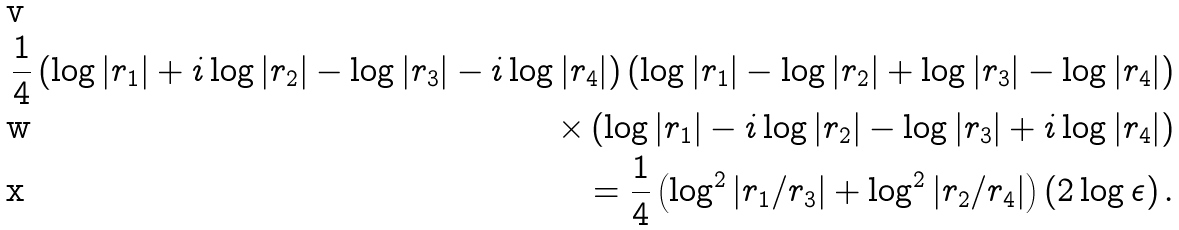Convert formula to latex. <formula><loc_0><loc_0><loc_500><loc_500>\frac { 1 } { 4 } \left ( \log | r _ { 1 } | + i \log | r _ { 2 } | - \log | r _ { 3 } | - i \log | r _ { 4 } | \right ) \left ( \log | r _ { 1 } | - \log | r _ { 2 } | + \log | r _ { 3 } | - \log | r _ { 4 } | \right ) \\ \times \left ( \log | r _ { 1 } | - i \log | r _ { 2 } | - \log | r _ { 3 } | + i \log | r _ { 4 } | \right ) \\ = \frac { 1 } { 4 } \left ( \log ^ { 2 } | r _ { 1 } / r _ { 3 } | + \log ^ { 2 } | r _ { 2 } / r _ { 4 } | \right ) \left ( 2 \log \epsilon \right ) .</formula> 